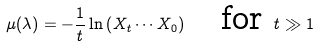<formula> <loc_0><loc_0><loc_500><loc_500>\mu ( \lambda ) = - \frac { 1 } { t } \ln \left ( X _ { t } \cdots X _ { 0 } \right ) \quad \text {for } t \gg 1</formula> 